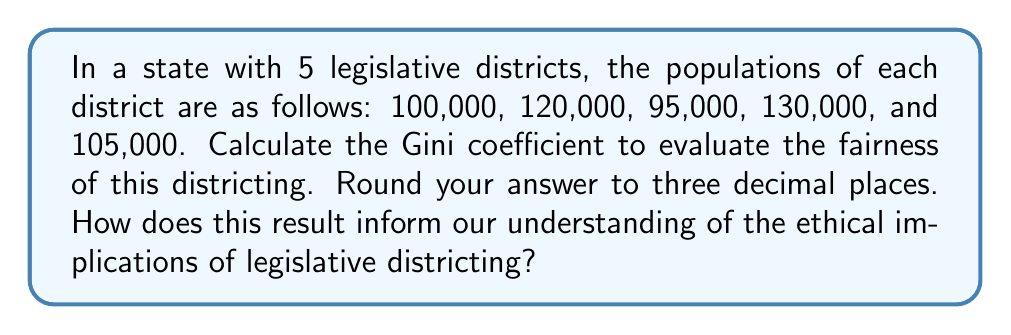Show me your answer to this math problem. To calculate the Gini coefficient for legislative districting fairness:

1. Calculate the mean population:
   $\mu = \frac{100000 + 120000 + 95000 + 130000 + 105000}{5} = 110000$

2. Calculate absolute differences between each pair of districts:
   $|100000 - 120000| = 20000$
   $|100000 - 95000| = 5000$
   $|100000 - 130000| = 30000$
   $|100000 - 105000| = 5000$
   $|120000 - 95000| = 25000$
   $|120000 - 130000| = 10000$
   $|120000 - 105000| = 15000$
   $|95000 - 130000| = 35000$
   $|95000 - 105000| = 10000$
   $|130000 - 105000| = 25000$

3. Sum all absolute differences:
   $\sum |x_i - x_j| = 180000$

4. Apply the Gini coefficient formula:
   $$G = \frac{\sum_{i=1}^n \sum_{j=1}^n |x_i - x_j|}{2n^2\mu}$$
   
   Where $n$ is the number of districts (5) and $\mu$ is the mean population (110000).

   $$G = \frac{180000}{2 * 5^2 * 110000} = \frac{180000}{5500000} \approx 0.0327$$

5. Round to three decimal places: 0.033

The Gini coefficient ranges from 0 (perfect equality) to 1 (perfect inequality). A value of 0.033 indicates relatively low inequality in district populations, suggesting a fairly even distribution. However, this measure alone doesn't account for other factors like geographical compactness or community cohesion.

Ethically, while this districting appears numerically fair, we must consider whether it adequately represents diverse communities and ensures equitable political representation. The editor should encourage deeper exploration of how mathematical measures like the Gini coefficient can inform, but not solely determine, the ethics of legislative districting.
Answer: 0.033 